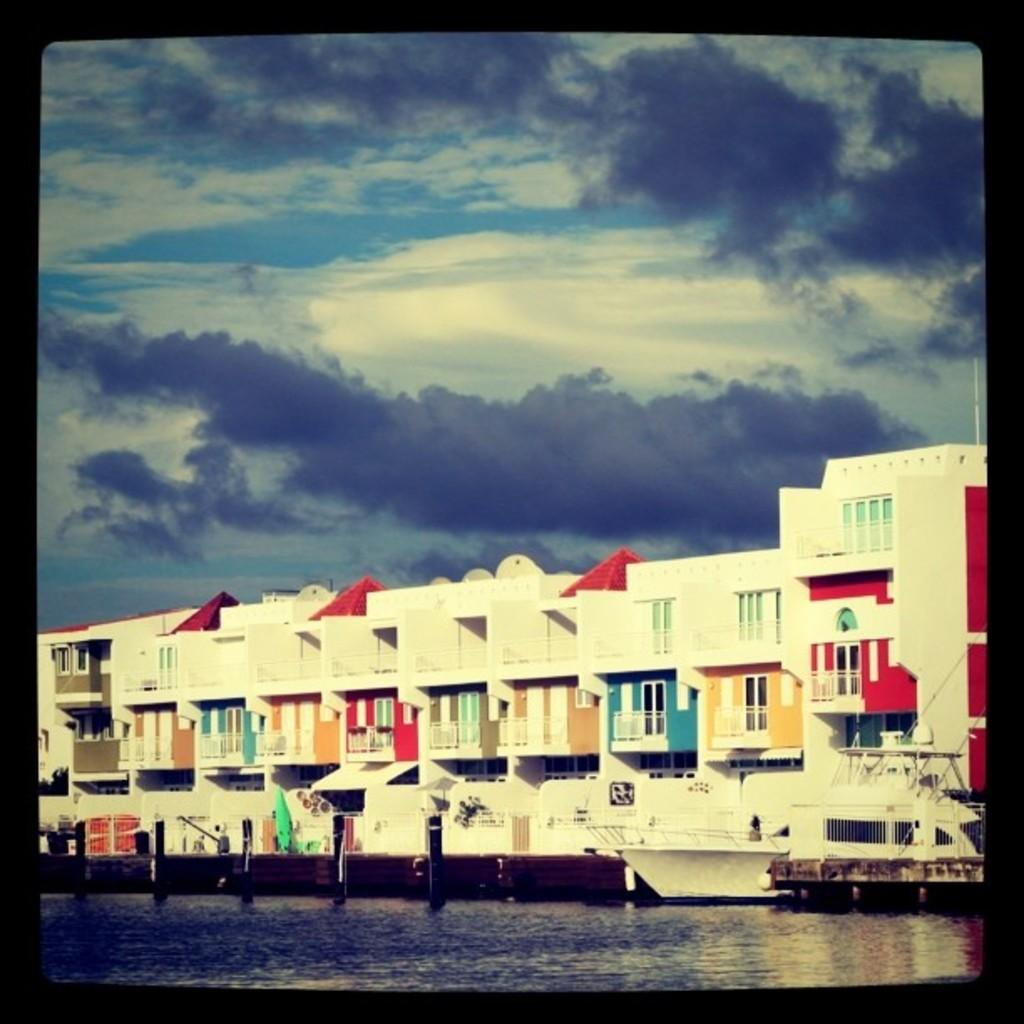What is located in the front of the image? There is water in the front of the image. What can be seen in the background of the image? There is a ship and buildings in the background of the image. What is the condition of the sky in the image? The sky is cloudy in the image. Can you describe the partner's reaction to the wall in the image? There is no partner or wall present in the image. What are the hands of the people in the image doing? There are no people present in the image, only water, a ship, buildings, and a cloudy sky. 